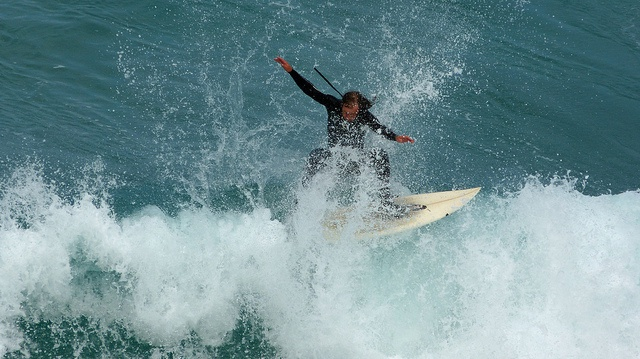Describe the objects in this image and their specific colors. I can see people in teal, black, gray, and darkgray tones and surfboard in teal, darkgray, lightblue, and beige tones in this image. 